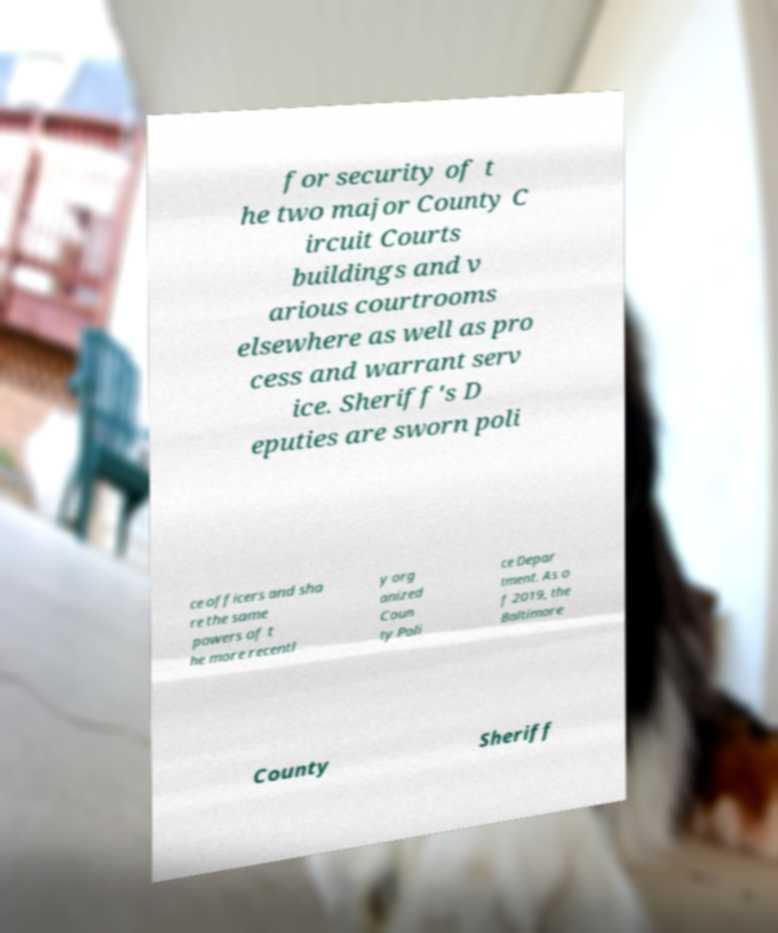For documentation purposes, I need the text within this image transcribed. Could you provide that? for security of t he two major County C ircuit Courts buildings and v arious courtrooms elsewhere as well as pro cess and warrant serv ice. Sheriff's D eputies are sworn poli ce officers and sha re the same powers of t he more recentl y org anized Coun ty Poli ce Depar tment. As o f 2019, the Baltimore County Sheriff 